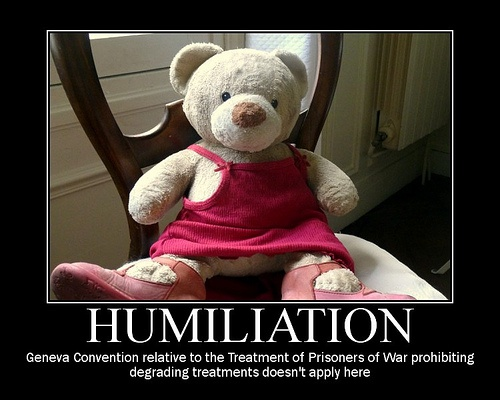Describe the objects in this image and their specific colors. I can see teddy bear in black, maroon, beige, and gray tones, chair in black, gray, and maroon tones, and chair in black, gray, and darkgray tones in this image. 